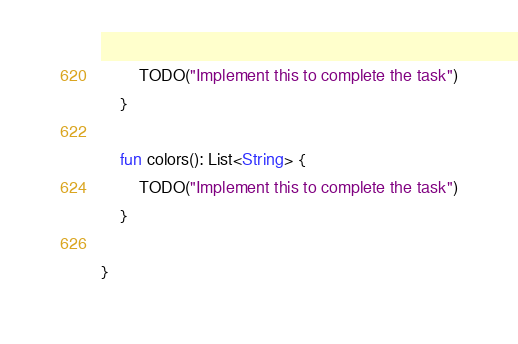Convert code to text. <code><loc_0><loc_0><loc_500><loc_500><_Kotlin_>        TODO("Implement this to complete the task")
    }

    fun colors(): List<String> {
        TODO("Implement this to complete the task")
    }

}
</code> 